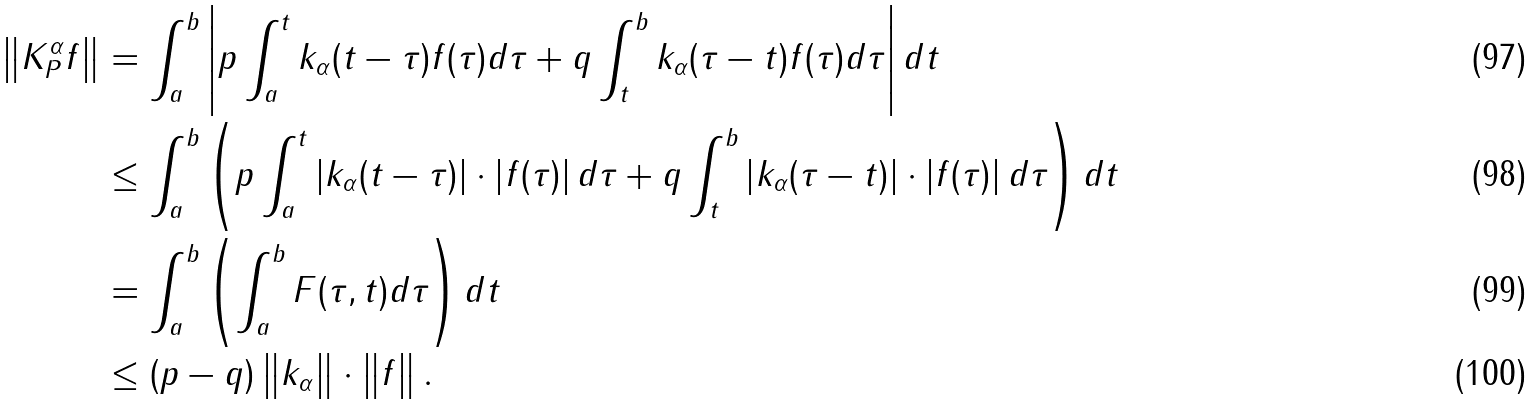<formula> <loc_0><loc_0><loc_500><loc_500>\left \| K _ { P } ^ { \alpha } f \right \| & = \int _ { a } ^ { b } \left | p \int _ { a } ^ { t } k _ { \alpha } ( t - \tau ) f ( \tau ) d \tau + q \int _ { t } ^ { b } k _ { \alpha } ( \tau - t ) f ( \tau ) d \tau \right | d t \\ & \leq \int _ { a } ^ { b } \left ( p \int _ { a } ^ { t } \left | k _ { \alpha } ( t - \tau ) \right | \cdot \left | f ( \tau ) \right | d \tau + q \int _ { t } ^ { b } \left | k _ { \alpha } ( \tau - t ) \right | \cdot \left | f ( \tau ) \right | d \tau \right ) d t \\ & = \int _ { a } ^ { b } \left ( \int _ { a } ^ { b } F ( \tau , t ) d \tau \right ) d t \\ & \leq ( p - q ) \left \| k _ { \alpha } \right \| \cdot \left \| f \right \| .</formula> 